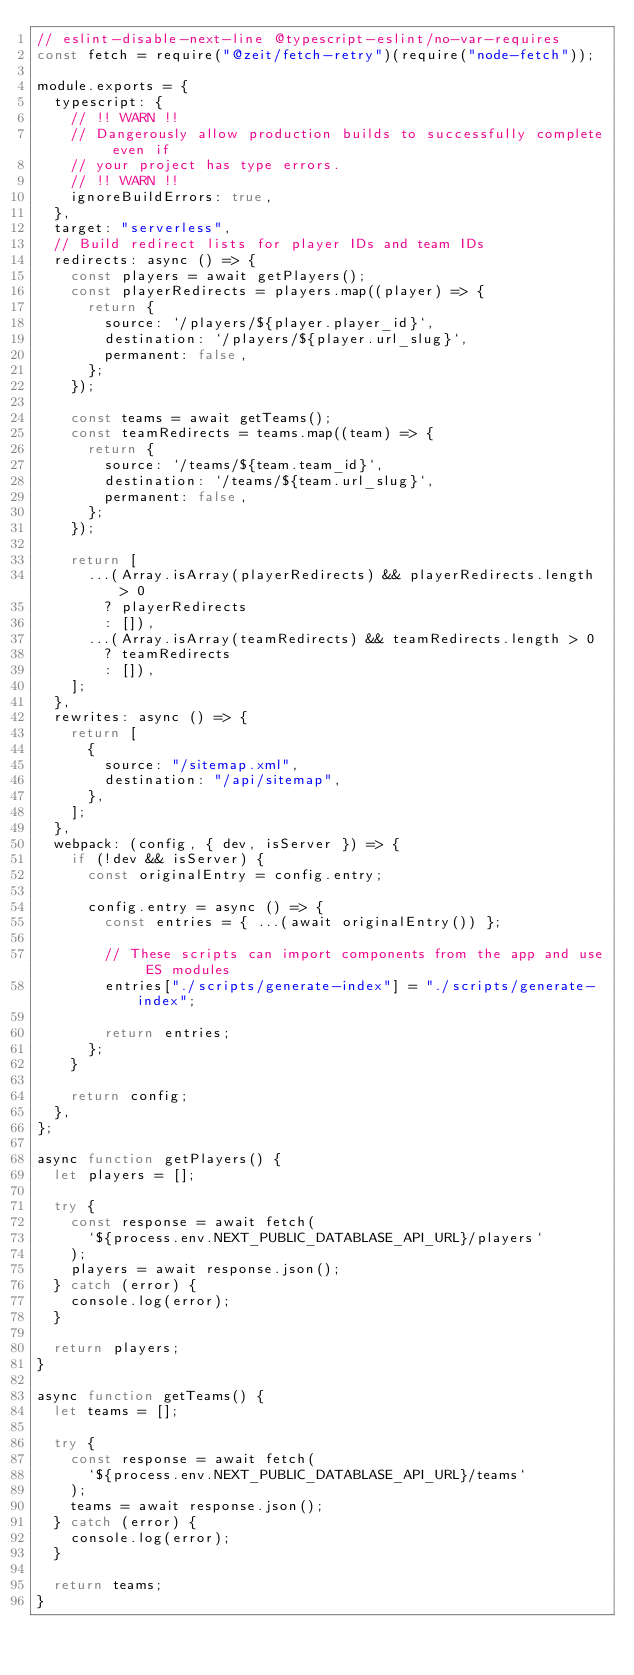<code> <loc_0><loc_0><loc_500><loc_500><_JavaScript_>// eslint-disable-next-line @typescript-eslint/no-var-requires
const fetch = require("@zeit/fetch-retry")(require("node-fetch"));

module.exports = {
  typescript: {
    // !! WARN !!
    // Dangerously allow production builds to successfully complete even if
    // your project has type errors.
    // !! WARN !!
    ignoreBuildErrors: true,
  },
  target: "serverless",
  // Build redirect lists for player IDs and team IDs
  redirects: async () => {
    const players = await getPlayers();
    const playerRedirects = players.map((player) => {
      return {
        source: `/players/${player.player_id}`,
        destination: `/players/${player.url_slug}`,
        permanent: false,
      };
    });

    const teams = await getTeams();
    const teamRedirects = teams.map((team) => {
      return {
        source: `/teams/${team.team_id}`,
        destination: `/teams/${team.url_slug}`,
        permanent: false,
      };
    });

    return [
      ...(Array.isArray(playerRedirects) && playerRedirects.length > 0
        ? playerRedirects
        : []),
      ...(Array.isArray(teamRedirects) && teamRedirects.length > 0
        ? teamRedirects
        : []),
    ];
  },
  rewrites: async () => {
    return [
      {
        source: "/sitemap.xml",
        destination: "/api/sitemap",
      },
    ];
  },
  webpack: (config, { dev, isServer }) => {
    if (!dev && isServer) {
      const originalEntry = config.entry;

      config.entry = async () => {
        const entries = { ...(await originalEntry()) };

        // These scripts can import components from the app and use ES modules
        entries["./scripts/generate-index"] = "./scripts/generate-index";

        return entries;
      };
    }

    return config;
  },
};

async function getPlayers() {
  let players = [];

  try {
    const response = await fetch(
      `${process.env.NEXT_PUBLIC_DATABLASE_API_URL}/players`
    );
    players = await response.json();
  } catch (error) {
    console.log(error);
  }

  return players;
}

async function getTeams() {
  let teams = [];

  try {
    const response = await fetch(
      `${process.env.NEXT_PUBLIC_DATABLASE_API_URL}/teams`
    );
    teams = await response.json();
  } catch (error) {
    console.log(error);
  }

  return teams;
}
</code> 